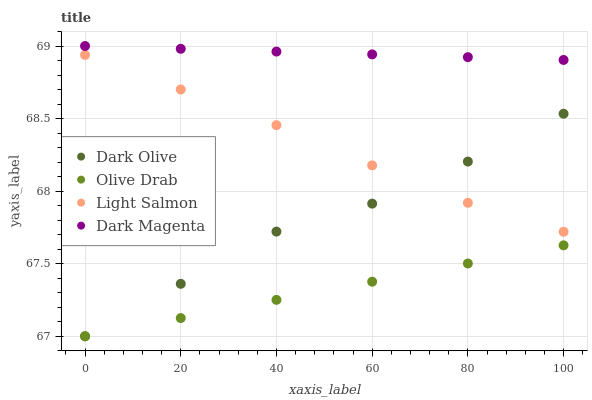Does Olive Drab have the minimum area under the curve?
Answer yes or no. Yes. Does Dark Magenta have the maximum area under the curve?
Answer yes or no. Yes. Does Dark Olive have the minimum area under the curve?
Answer yes or no. No. Does Dark Olive have the maximum area under the curve?
Answer yes or no. No. Is Dark Magenta the smoothest?
Answer yes or no. Yes. Is Dark Olive the roughest?
Answer yes or no. Yes. Is Dark Olive the smoothest?
Answer yes or no. No. Is Dark Magenta the roughest?
Answer yes or no. No. Does Dark Olive have the lowest value?
Answer yes or no. Yes. Does Dark Magenta have the lowest value?
Answer yes or no. No. Does Dark Magenta have the highest value?
Answer yes or no. Yes. Does Dark Olive have the highest value?
Answer yes or no. No. Is Olive Drab less than Light Salmon?
Answer yes or no. Yes. Is Dark Magenta greater than Olive Drab?
Answer yes or no. Yes. Does Olive Drab intersect Dark Olive?
Answer yes or no. Yes. Is Olive Drab less than Dark Olive?
Answer yes or no. No. Is Olive Drab greater than Dark Olive?
Answer yes or no. No. Does Olive Drab intersect Light Salmon?
Answer yes or no. No. 